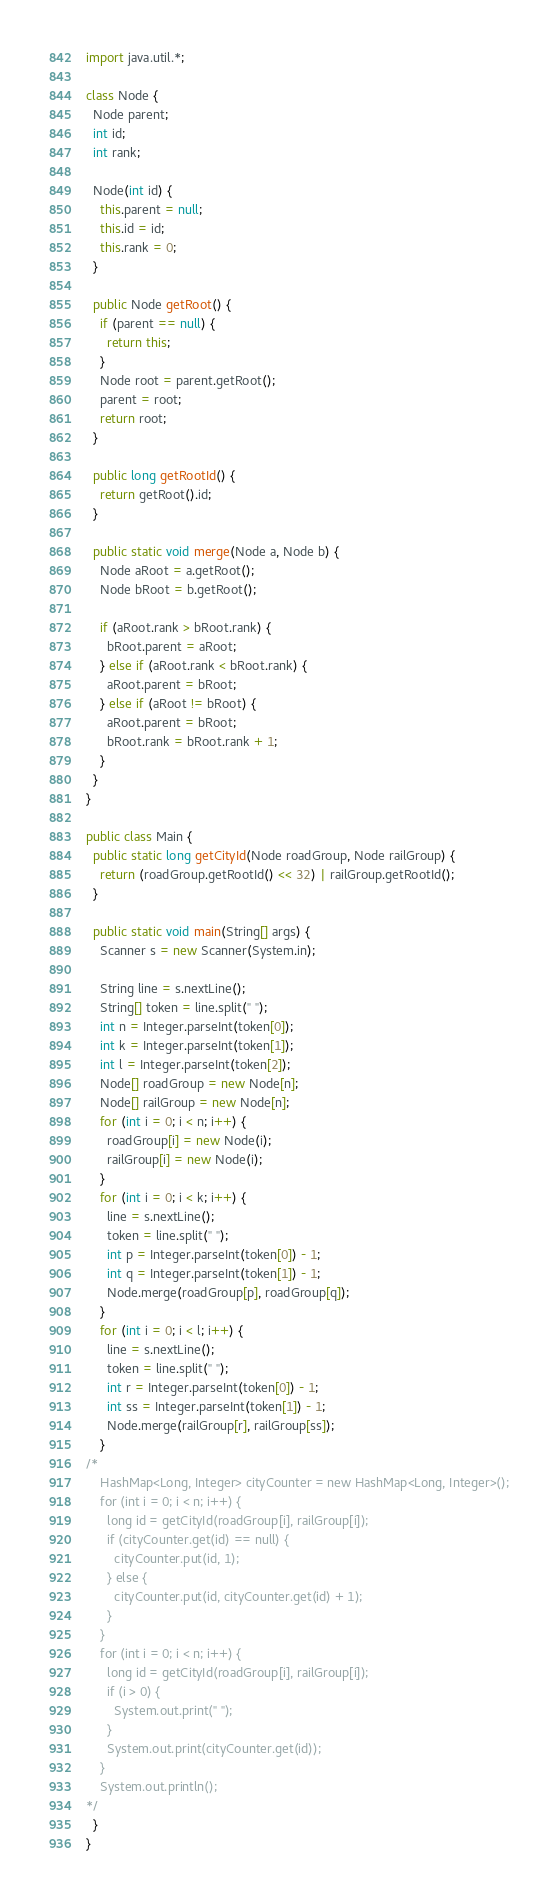Convert code to text. <code><loc_0><loc_0><loc_500><loc_500><_Java_>import java.util.*;

class Node {
  Node parent;
  int id;
  int rank;

  Node(int id) {
    this.parent = null;
    this.id = id;
    this.rank = 0;
  }

  public Node getRoot() {
    if (parent == null) {
      return this;
    }
    Node root = parent.getRoot();
    parent = root;
    return root;
  }

  public long getRootId() {
    return getRoot().id;
  }

  public static void merge(Node a, Node b) {
    Node aRoot = a.getRoot();
    Node bRoot = b.getRoot();

    if (aRoot.rank > bRoot.rank) {
      bRoot.parent = aRoot;
    } else if (aRoot.rank < bRoot.rank) {
      aRoot.parent = bRoot;
    } else if (aRoot != bRoot) {
      aRoot.parent = bRoot;
      bRoot.rank = bRoot.rank + 1;
    }
  }
}

public class Main {
  public static long getCityId(Node roadGroup, Node railGroup) {
    return (roadGroup.getRootId() << 32) | railGroup.getRootId();
  }

  public static void main(String[] args) {
    Scanner s = new Scanner(System.in);

    String line = s.nextLine();
    String[] token = line.split(" ");
    int n = Integer.parseInt(token[0]);
    int k = Integer.parseInt(token[1]);
    int l = Integer.parseInt(token[2]);
    Node[] roadGroup = new Node[n];
    Node[] railGroup = new Node[n];
    for (int i = 0; i < n; i++) {
      roadGroup[i] = new Node(i);
      railGroup[i] = new Node(i);
    }
    for (int i = 0; i < k; i++) {
      line = s.nextLine();
      token = line.split(" ");
      int p = Integer.parseInt(token[0]) - 1;
      int q = Integer.parseInt(token[1]) - 1;
      Node.merge(roadGroup[p], roadGroup[q]);
    }
    for (int i = 0; i < l; i++) {
      line = s.nextLine();
      token = line.split(" ");
      int r = Integer.parseInt(token[0]) - 1;
      int ss = Integer.parseInt(token[1]) - 1;
      Node.merge(railGroup[r], railGroup[ss]);
    }
/*
    HashMap<Long, Integer> cityCounter = new HashMap<Long, Integer>();
    for (int i = 0; i < n; i++) {
      long id = getCityId(roadGroup[i], railGroup[i]);
      if (cityCounter.get(id) == null) {
        cityCounter.put(id, 1);
      } else {
        cityCounter.put(id, cityCounter.get(id) + 1);
      }
    }
    for (int i = 0; i < n; i++) {
      long id = getCityId(roadGroup[i], railGroup[i]);
      if (i > 0) {
        System.out.print(" ");
      }
      System.out.print(cityCounter.get(id));
    }
    System.out.println();
*/
  }
}
</code> 